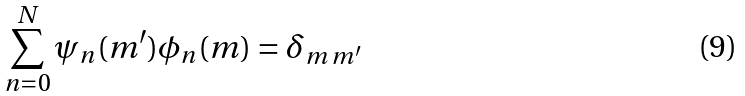Convert formula to latex. <formula><loc_0><loc_0><loc_500><loc_500>\sum _ { n = 0 } ^ { N } \psi _ { n } ( m ^ { \prime } ) \phi _ { n } ( m ) = \delta _ { m \, m ^ { \prime } }</formula> 